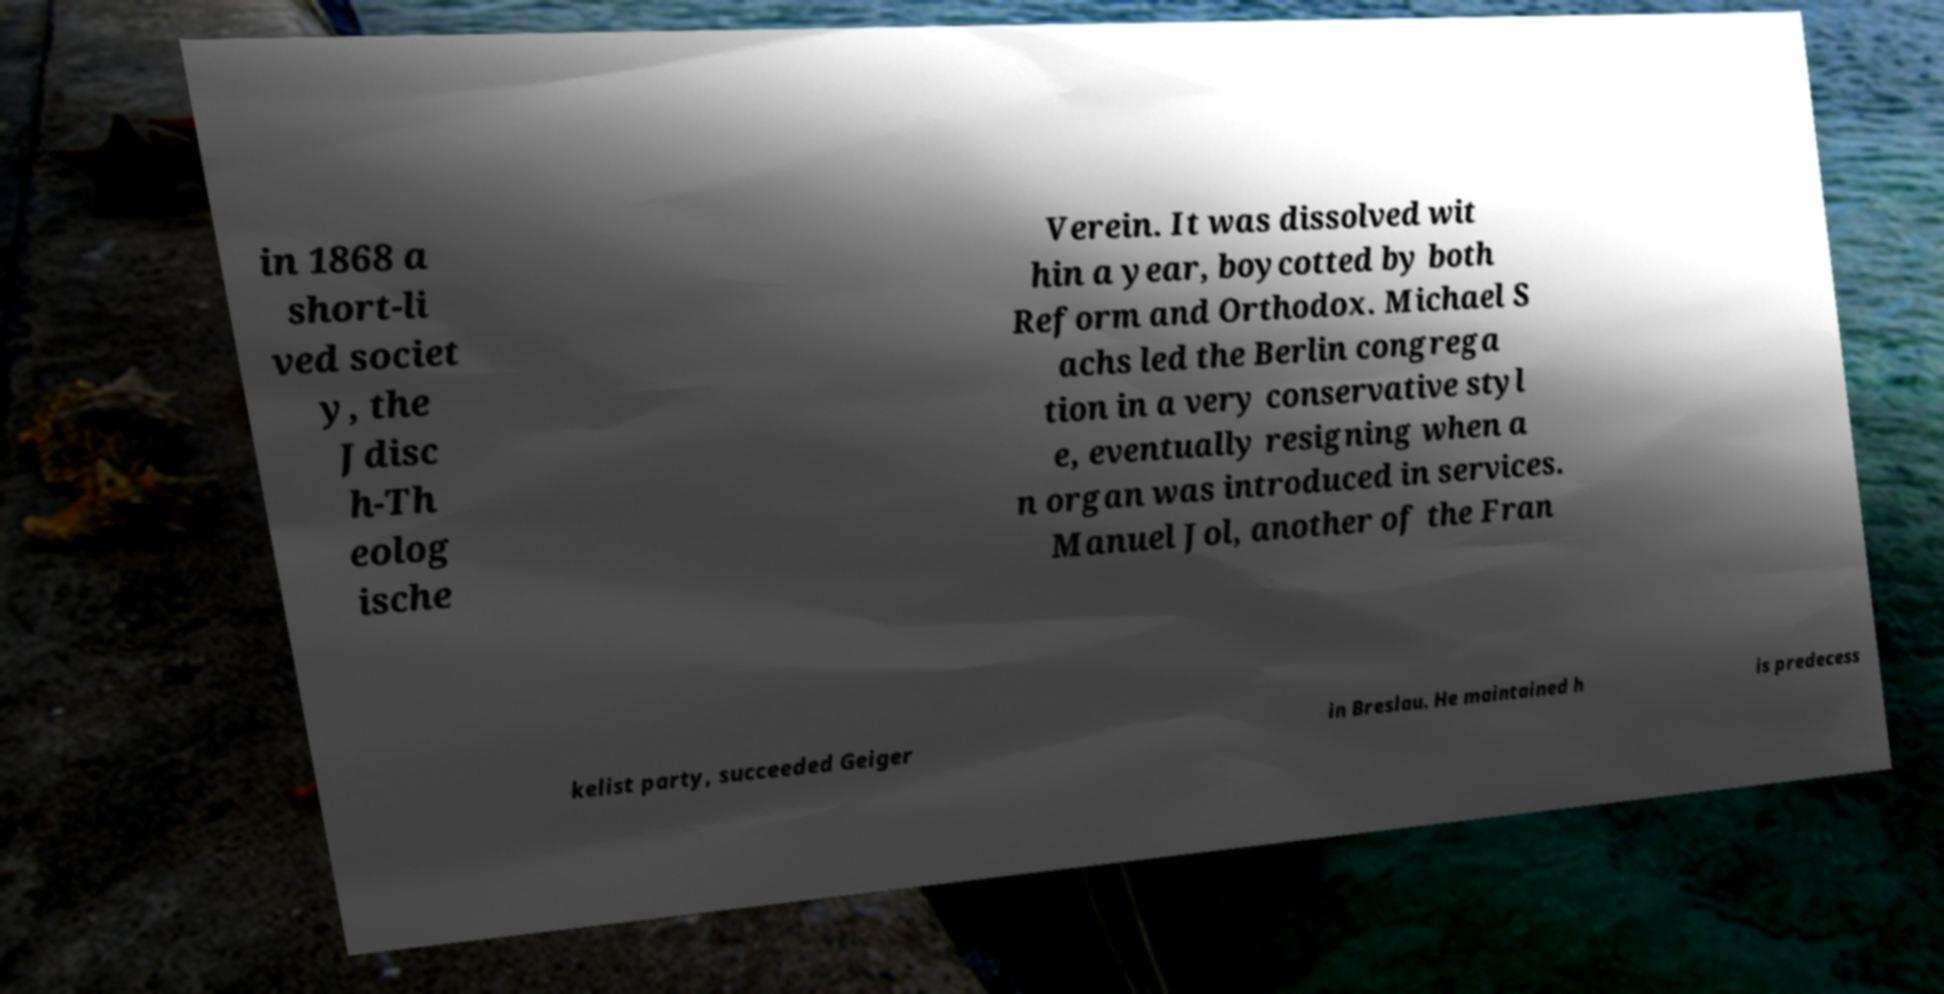Could you assist in decoding the text presented in this image and type it out clearly? in 1868 a short-li ved societ y, the Jdisc h-Th eolog ische Verein. It was dissolved wit hin a year, boycotted by both Reform and Orthodox. Michael S achs led the Berlin congrega tion in a very conservative styl e, eventually resigning when a n organ was introduced in services. Manuel Jol, another of the Fran kelist party, succeeded Geiger in Breslau. He maintained h is predecess 